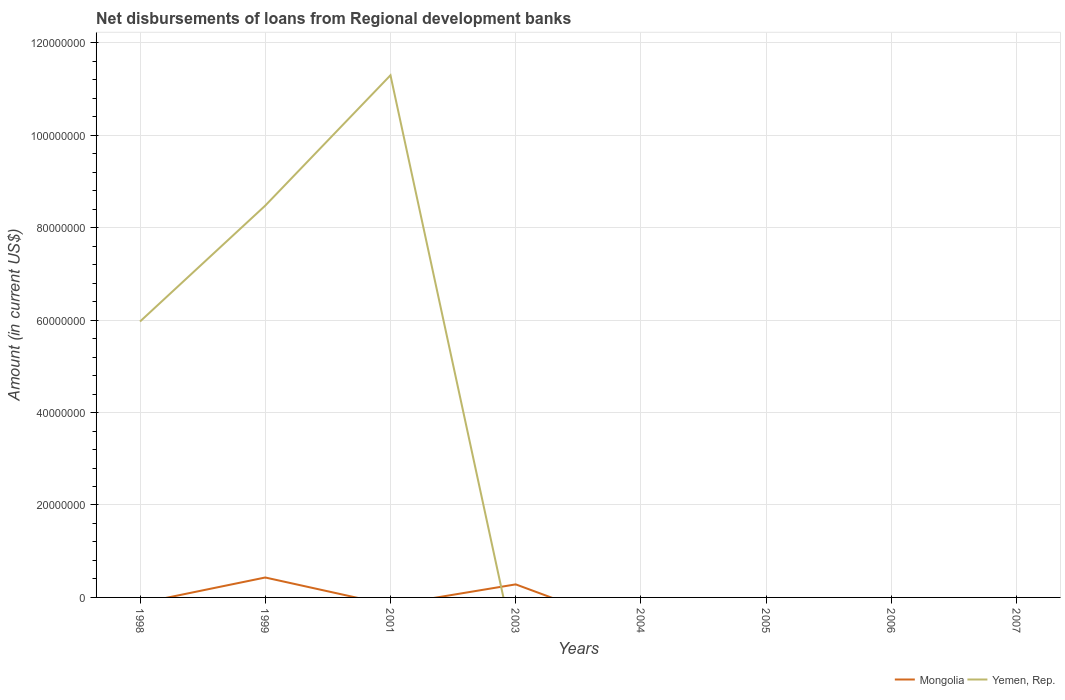How many different coloured lines are there?
Offer a very short reply. 2. What is the difference between the highest and the second highest amount of disbursements of loans from regional development banks in Mongolia?
Make the answer very short. 4.31e+06. What is the difference between the highest and the lowest amount of disbursements of loans from regional development banks in Yemen, Rep.?
Offer a terse response. 3. Does the graph contain any zero values?
Give a very brief answer. Yes. Does the graph contain grids?
Your answer should be very brief. Yes. Where does the legend appear in the graph?
Offer a terse response. Bottom right. How many legend labels are there?
Offer a terse response. 2. What is the title of the graph?
Provide a short and direct response. Net disbursements of loans from Regional development banks. What is the label or title of the X-axis?
Your answer should be very brief. Years. What is the label or title of the Y-axis?
Ensure brevity in your answer.  Amount (in current US$). What is the Amount (in current US$) of Mongolia in 1998?
Offer a terse response. 0. What is the Amount (in current US$) in Yemen, Rep. in 1998?
Provide a succinct answer. 5.97e+07. What is the Amount (in current US$) of Mongolia in 1999?
Ensure brevity in your answer.  4.31e+06. What is the Amount (in current US$) of Yemen, Rep. in 1999?
Give a very brief answer. 8.48e+07. What is the Amount (in current US$) of Yemen, Rep. in 2001?
Keep it short and to the point. 1.13e+08. What is the Amount (in current US$) of Mongolia in 2003?
Ensure brevity in your answer.  2.82e+06. What is the Amount (in current US$) in Mongolia in 2004?
Provide a succinct answer. 0. What is the Amount (in current US$) in Yemen, Rep. in 2004?
Keep it short and to the point. 0. What is the Amount (in current US$) of Mongolia in 2005?
Offer a terse response. 0. Across all years, what is the maximum Amount (in current US$) in Mongolia?
Make the answer very short. 4.31e+06. Across all years, what is the maximum Amount (in current US$) in Yemen, Rep.?
Your answer should be very brief. 1.13e+08. What is the total Amount (in current US$) in Mongolia in the graph?
Ensure brevity in your answer.  7.14e+06. What is the total Amount (in current US$) of Yemen, Rep. in the graph?
Your answer should be very brief. 2.57e+08. What is the difference between the Amount (in current US$) of Yemen, Rep. in 1998 and that in 1999?
Offer a terse response. -2.51e+07. What is the difference between the Amount (in current US$) of Yemen, Rep. in 1998 and that in 2001?
Your answer should be very brief. -5.33e+07. What is the difference between the Amount (in current US$) in Yemen, Rep. in 1999 and that in 2001?
Make the answer very short. -2.82e+07. What is the difference between the Amount (in current US$) in Mongolia in 1999 and that in 2003?
Ensure brevity in your answer.  1.49e+06. What is the difference between the Amount (in current US$) in Mongolia in 1999 and the Amount (in current US$) in Yemen, Rep. in 2001?
Provide a succinct answer. -1.09e+08. What is the average Amount (in current US$) of Mongolia per year?
Ensure brevity in your answer.  8.92e+05. What is the average Amount (in current US$) in Yemen, Rep. per year?
Offer a terse response. 3.22e+07. In the year 1999, what is the difference between the Amount (in current US$) of Mongolia and Amount (in current US$) of Yemen, Rep.?
Your answer should be very brief. -8.05e+07. What is the ratio of the Amount (in current US$) in Yemen, Rep. in 1998 to that in 1999?
Provide a succinct answer. 0.7. What is the ratio of the Amount (in current US$) in Yemen, Rep. in 1998 to that in 2001?
Give a very brief answer. 0.53. What is the ratio of the Amount (in current US$) of Yemen, Rep. in 1999 to that in 2001?
Offer a terse response. 0.75. What is the ratio of the Amount (in current US$) in Mongolia in 1999 to that in 2003?
Your answer should be very brief. 1.53. What is the difference between the highest and the second highest Amount (in current US$) of Yemen, Rep.?
Give a very brief answer. 2.82e+07. What is the difference between the highest and the lowest Amount (in current US$) of Mongolia?
Make the answer very short. 4.31e+06. What is the difference between the highest and the lowest Amount (in current US$) of Yemen, Rep.?
Your answer should be very brief. 1.13e+08. 